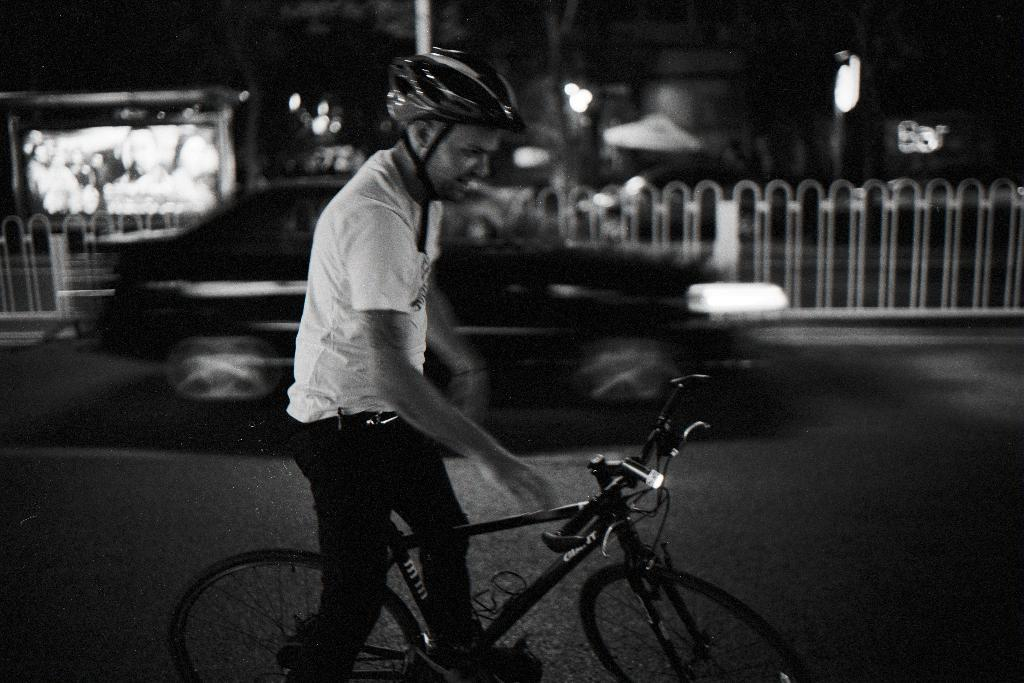What objects are visible in the image that emit light? There are lights in the image. Can you describe the person in the image? There is a man in the image. What mode of transportation is present in the image? There is a bicycle in the image. How many knives are being used to cut the bicycle in the image? There are no knives present in the image, nor is the bicycle being cut. What type of flock is flying over the man in the image? There is no flock present in the image; it only features a man, lights, and a bicycle. 